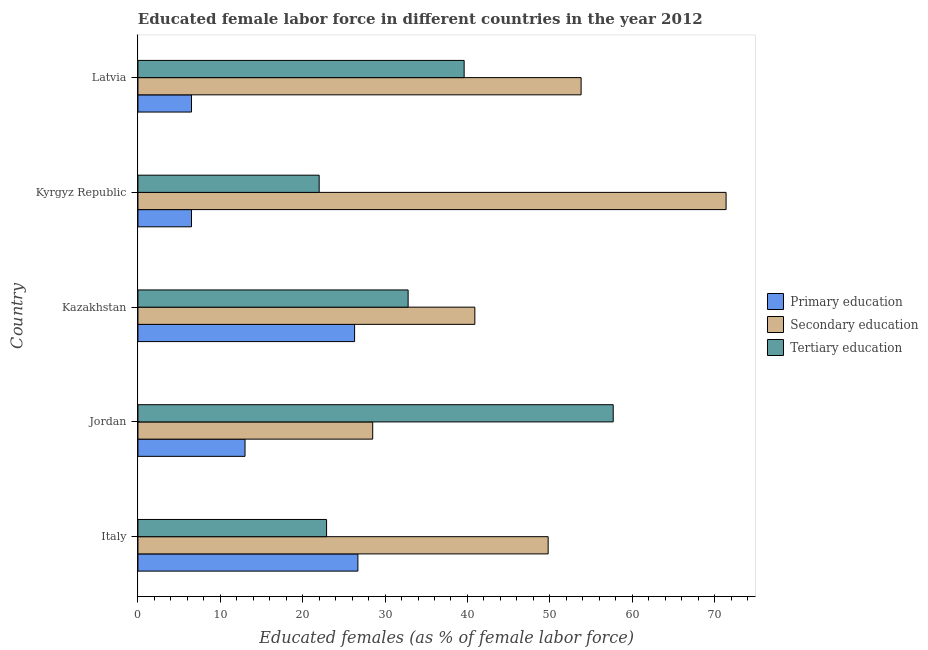How many different coloured bars are there?
Your response must be concise. 3. How many groups of bars are there?
Your response must be concise. 5. Are the number of bars per tick equal to the number of legend labels?
Your answer should be compact. Yes. How many bars are there on the 4th tick from the top?
Provide a short and direct response. 3. What is the label of the 2nd group of bars from the top?
Ensure brevity in your answer.  Kyrgyz Republic. Across all countries, what is the maximum percentage of female labor force who received tertiary education?
Your response must be concise. 57.7. Across all countries, what is the minimum percentage of female labor force who received secondary education?
Provide a short and direct response. 28.5. In which country was the percentage of female labor force who received secondary education minimum?
Keep it short and to the point. Jordan. What is the total percentage of female labor force who received secondary education in the graph?
Your answer should be compact. 244.4. What is the difference between the percentage of female labor force who received primary education in Italy and that in Jordan?
Provide a succinct answer. 13.7. What is the difference between the percentage of female labor force who received primary education in Kyrgyz Republic and the percentage of female labor force who received tertiary education in Italy?
Offer a very short reply. -16.4. What is the average percentage of female labor force who received primary education per country?
Make the answer very short. 15.8. What is the difference between the percentage of female labor force who received secondary education and percentage of female labor force who received tertiary education in Kyrgyz Republic?
Make the answer very short. 49.4. In how many countries, is the percentage of female labor force who received tertiary education greater than 58 %?
Offer a terse response. 0. What is the ratio of the percentage of female labor force who received tertiary education in Italy to that in Kazakhstan?
Ensure brevity in your answer.  0.7. What is the difference between the highest and the second highest percentage of female labor force who received primary education?
Your response must be concise. 0.4. What is the difference between the highest and the lowest percentage of female labor force who received tertiary education?
Offer a terse response. 35.7. In how many countries, is the percentage of female labor force who received secondary education greater than the average percentage of female labor force who received secondary education taken over all countries?
Your answer should be compact. 3. Is the sum of the percentage of female labor force who received tertiary education in Italy and Latvia greater than the maximum percentage of female labor force who received primary education across all countries?
Provide a short and direct response. Yes. What does the 2nd bar from the top in Kyrgyz Republic represents?
Keep it short and to the point. Secondary education. What does the 2nd bar from the bottom in Jordan represents?
Offer a terse response. Secondary education. How many countries are there in the graph?
Ensure brevity in your answer.  5. What is the difference between two consecutive major ticks on the X-axis?
Offer a very short reply. 10. Are the values on the major ticks of X-axis written in scientific E-notation?
Ensure brevity in your answer.  No. Does the graph contain any zero values?
Your answer should be compact. No. Does the graph contain grids?
Ensure brevity in your answer.  No. What is the title of the graph?
Keep it short and to the point. Educated female labor force in different countries in the year 2012. What is the label or title of the X-axis?
Offer a terse response. Educated females (as % of female labor force). What is the Educated females (as % of female labor force) in Primary education in Italy?
Your response must be concise. 26.7. What is the Educated females (as % of female labor force) of Secondary education in Italy?
Keep it short and to the point. 49.8. What is the Educated females (as % of female labor force) of Tertiary education in Italy?
Keep it short and to the point. 22.9. What is the Educated females (as % of female labor force) in Secondary education in Jordan?
Offer a very short reply. 28.5. What is the Educated females (as % of female labor force) of Tertiary education in Jordan?
Provide a succinct answer. 57.7. What is the Educated females (as % of female labor force) in Primary education in Kazakhstan?
Offer a terse response. 26.3. What is the Educated females (as % of female labor force) of Secondary education in Kazakhstan?
Ensure brevity in your answer.  40.9. What is the Educated females (as % of female labor force) of Tertiary education in Kazakhstan?
Your answer should be very brief. 32.8. What is the Educated females (as % of female labor force) in Secondary education in Kyrgyz Republic?
Keep it short and to the point. 71.4. What is the Educated females (as % of female labor force) of Secondary education in Latvia?
Ensure brevity in your answer.  53.8. What is the Educated females (as % of female labor force) of Tertiary education in Latvia?
Offer a very short reply. 39.6. Across all countries, what is the maximum Educated females (as % of female labor force) in Primary education?
Offer a very short reply. 26.7. Across all countries, what is the maximum Educated females (as % of female labor force) in Secondary education?
Your answer should be compact. 71.4. Across all countries, what is the maximum Educated females (as % of female labor force) of Tertiary education?
Provide a short and direct response. 57.7. Across all countries, what is the minimum Educated females (as % of female labor force) of Primary education?
Give a very brief answer. 6.5. Across all countries, what is the minimum Educated females (as % of female labor force) in Secondary education?
Your response must be concise. 28.5. What is the total Educated females (as % of female labor force) in Primary education in the graph?
Offer a very short reply. 79. What is the total Educated females (as % of female labor force) of Secondary education in the graph?
Give a very brief answer. 244.4. What is the total Educated females (as % of female labor force) of Tertiary education in the graph?
Provide a short and direct response. 175. What is the difference between the Educated females (as % of female labor force) of Secondary education in Italy and that in Jordan?
Offer a terse response. 21.3. What is the difference between the Educated females (as % of female labor force) in Tertiary education in Italy and that in Jordan?
Offer a very short reply. -34.8. What is the difference between the Educated females (as % of female labor force) of Tertiary education in Italy and that in Kazakhstan?
Your response must be concise. -9.9. What is the difference between the Educated females (as % of female labor force) of Primary education in Italy and that in Kyrgyz Republic?
Your response must be concise. 20.2. What is the difference between the Educated females (as % of female labor force) in Secondary education in Italy and that in Kyrgyz Republic?
Keep it short and to the point. -21.6. What is the difference between the Educated females (as % of female labor force) in Tertiary education in Italy and that in Kyrgyz Republic?
Give a very brief answer. 0.9. What is the difference between the Educated females (as % of female labor force) of Primary education in Italy and that in Latvia?
Give a very brief answer. 20.2. What is the difference between the Educated females (as % of female labor force) of Tertiary education in Italy and that in Latvia?
Ensure brevity in your answer.  -16.7. What is the difference between the Educated females (as % of female labor force) of Secondary education in Jordan and that in Kazakhstan?
Ensure brevity in your answer.  -12.4. What is the difference between the Educated females (as % of female labor force) in Tertiary education in Jordan and that in Kazakhstan?
Your response must be concise. 24.9. What is the difference between the Educated females (as % of female labor force) of Secondary education in Jordan and that in Kyrgyz Republic?
Offer a very short reply. -42.9. What is the difference between the Educated females (as % of female labor force) in Tertiary education in Jordan and that in Kyrgyz Republic?
Your response must be concise. 35.7. What is the difference between the Educated females (as % of female labor force) in Secondary education in Jordan and that in Latvia?
Provide a short and direct response. -25.3. What is the difference between the Educated females (as % of female labor force) of Tertiary education in Jordan and that in Latvia?
Offer a terse response. 18.1. What is the difference between the Educated females (as % of female labor force) in Primary education in Kazakhstan and that in Kyrgyz Republic?
Provide a short and direct response. 19.8. What is the difference between the Educated females (as % of female labor force) of Secondary education in Kazakhstan and that in Kyrgyz Republic?
Your answer should be very brief. -30.5. What is the difference between the Educated females (as % of female labor force) of Primary education in Kazakhstan and that in Latvia?
Your answer should be compact. 19.8. What is the difference between the Educated females (as % of female labor force) of Secondary education in Kazakhstan and that in Latvia?
Your answer should be very brief. -12.9. What is the difference between the Educated females (as % of female labor force) in Tertiary education in Kazakhstan and that in Latvia?
Ensure brevity in your answer.  -6.8. What is the difference between the Educated females (as % of female labor force) in Primary education in Kyrgyz Republic and that in Latvia?
Give a very brief answer. 0. What is the difference between the Educated females (as % of female labor force) of Secondary education in Kyrgyz Republic and that in Latvia?
Make the answer very short. 17.6. What is the difference between the Educated females (as % of female labor force) in Tertiary education in Kyrgyz Republic and that in Latvia?
Your response must be concise. -17.6. What is the difference between the Educated females (as % of female labor force) in Primary education in Italy and the Educated females (as % of female labor force) in Secondary education in Jordan?
Ensure brevity in your answer.  -1.8. What is the difference between the Educated females (as % of female labor force) of Primary education in Italy and the Educated females (as % of female labor force) of Tertiary education in Jordan?
Offer a terse response. -31. What is the difference between the Educated females (as % of female labor force) of Secondary education in Italy and the Educated females (as % of female labor force) of Tertiary education in Jordan?
Keep it short and to the point. -7.9. What is the difference between the Educated females (as % of female labor force) of Secondary education in Italy and the Educated females (as % of female labor force) of Tertiary education in Kazakhstan?
Your answer should be very brief. 17. What is the difference between the Educated females (as % of female labor force) in Primary education in Italy and the Educated females (as % of female labor force) in Secondary education in Kyrgyz Republic?
Your answer should be compact. -44.7. What is the difference between the Educated females (as % of female labor force) of Primary education in Italy and the Educated females (as % of female labor force) of Tertiary education in Kyrgyz Republic?
Provide a succinct answer. 4.7. What is the difference between the Educated females (as % of female labor force) in Secondary education in Italy and the Educated females (as % of female labor force) in Tertiary education in Kyrgyz Republic?
Offer a terse response. 27.8. What is the difference between the Educated females (as % of female labor force) of Primary education in Italy and the Educated females (as % of female labor force) of Secondary education in Latvia?
Your response must be concise. -27.1. What is the difference between the Educated females (as % of female labor force) in Secondary education in Italy and the Educated females (as % of female labor force) in Tertiary education in Latvia?
Offer a terse response. 10.2. What is the difference between the Educated females (as % of female labor force) of Primary education in Jordan and the Educated females (as % of female labor force) of Secondary education in Kazakhstan?
Give a very brief answer. -27.9. What is the difference between the Educated females (as % of female labor force) of Primary education in Jordan and the Educated females (as % of female labor force) of Tertiary education in Kazakhstan?
Ensure brevity in your answer.  -19.8. What is the difference between the Educated females (as % of female labor force) in Primary education in Jordan and the Educated females (as % of female labor force) in Secondary education in Kyrgyz Republic?
Your answer should be compact. -58.4. What is the difference between the Educated females (as % of female labor force) of Primary education in Jordan and the Educated females (as % of female labor force) of Tertiary education in Kyrgyz Republic?
Ensure brevity in your answer.  -9. What is the difference between the Educated females (as % of female labor force) of Primary education in Jordan and the Educated females (as % of female labor force) of Secondary education in Latvia?
Provide a short and direct response. -40.8. What is the difference between the Educated females (as % of female labor force) in Primary education in Jordan and the Educated females (as % of female labor force) in Tertiary education in Latvia?
Provide a succinct answer. -26.6. What is the difference between the Educated females (as % of female labor force) of Primary education in Kazakhstan and the Educated females (as % of female labor force) of Secondary education in Kyrgyz Republic?
Provide a succinct answer. -45.1. What is the difference between the Educated females (as % of female labor force) in Primary education in Kazakhstan and the Educated females (as % of female labor force) in Secondary education in Latvia?
Keep it short and to the point. -27.5. What is the difference between the Educated females (as % of female labor force) in Primary education in Kazakhstan and the Educated females (as % of female labor force) in Tertiary education in Latvia?
Provide a short and direct response. -13.3. What is the difference between the Educated females (as % of female labor force) in Primary education in Kyrgyz Republic and the Educated females (as % of female labor force) in Secondary education in Latvia?
Provide a short and direct response. -47.3. What is the difference between the Educated females (as % of female labor force) in Primary education in Kyrgyz Republic and the Educated females (as % of female labor force) in Tertiary education in Latvia?
Your answer should be very brief. -33.1. What is the difference between the Educated females (as % of female labor force) of Secondary education in Kyrgyz Republic and the Educated females (as % of female labor force) of Tertiary education in Latvia?
Your answer should be compact. 31.8. What is the average Educated females (as % of female labor force) in Primary education per country?
Your response must be concise. 15.8. What is the average Educated females (as % of female labor force) in Secondary education per country?
Give a very brief answer. 48.88. What is the average Educated females (as % of female labor force) of Tertiary education per country?
Provide a succinct answer. 35. What is the difference between the Educated females (as % of female labor force) of Primary education and Educated females (as % of female labor force) of Secondary education in Italy?
Your answer should be very brief. -23.1. What is the difference between the Educated females (as % of female labor force) in Primary education and Educated females (as % of female labor force) in Tertiary education in Italy?
Offer a terse response. 3.8. What is the difference between the Educated females (as % of female labor force) in Secondary education and Educated females (as % of female labor force) in Tertiary education in Italy?
Give a very brief answer. 26.9. What is the difference between the Educated females (as % of female labor force) in Primary education and Educated females (as % of female labor force) in Secondary education in Jordan?
Provide a short and direct response. -15.5. What is the difference between the Educated females (as % of female labor force) in Primary education and Educated females (as % of female labor force) in Tertiary education in Jordan?
Your answer should be very brief. -44.7. What is the difference between the Educated females (as % of female labor force) of Secondary education and Educated females (as % of female labor force) of Tertiary education in Jordan?
Ensure brevity in your answer.  -29.2. What is the difference between the Educated females (as % of female labor force) in Primary education and Educated females (as % of female labor force) in Secondary education in Kazakhstan?
Keep it short and to the point. -14.6. What is the difference between the Educated females (as % of female labor force) in Primary education and Educated females (as % of female labor force) in Tertiary education in Kazakhstan?
Your answer should be very brief. -6.5. What is the difference between the Educated females (as % of female labor force) of Primary education and Educated females (as % of female labor force) of Secondary education in Kyrgyz Republic?
Keep it short and to the point. -64.9. What is the difference between the Educated females (as % of female labor force) of Primary education and Educated females (as % of female labor force) of Tertiary education in Kyrgyz Republic?
Make the answer very short. -15.5. What is the difference between the Educated females (as % of female labor force) of Secondary education and Educated females (as % of female labor force) of Tertiary education in Kyrgyz Republic?
Your answer should be compact. 49.4. What is the difference between the Educated females (as % of female labor force) of Primary education and Educated females (as % of female labor force) of Secondary education in Latvia?
Make the answer very short. -47.3. What is the difference between the Educated females (as % of female labor force) in Primary education and Educated females (as % of female labor force) in Tertiary education in Latvia?
Ensure brevity in your answer.  -33.1. What is the difference between the Educated females (as % of female labor force) of Secondary education and Educated females (as % of female labor force) of Tertiary education in Latvia?
Provide a succinct answer. 14.2. What is the ratio of the Educated females (as % of female labor force) of Primary education in Italy to that in Jordan?
Your answer should be compact. 2.05. What is the ratio of the Educated females (as % of female labor force) of Secondary education in Italy to that in Jordan?
Your response must be concise. 1.75. What is the ratio of the Educated females (as % of female labor force) of Tertiary education in Italy to that in Jordan?
Give a very brief answer. 0.4. What is the ratio of the Educated females (as % of female labor force) in Primary education in Italy to that in Kazakhstan?
Give a very brief answer. 1.02. What is the ratio of the Educated females (as % of female labor force) of Secondary education in Italy to that in Kazakhstan?
Make the answer very short. 1.22. What is the ratio of the Educated females (as % of female labor force) of Tertiary education in Italy to that in Kazakhstan?
Offer a terse response. 0.7. What is the ratio of the Educated females (as % of female labor force) of Primary education in Italy to that in Kyrgyz Republic?
Give a very brief answer. 4.11. What is the ratio of the Educated females (as % of female labor force) of Secondary education in Italy to that in Kyrgyz Republic?
Offer a terse response. 0.7. What is the ratio of the Educated females (as % of female labor force) of Tertiary education in Italy to that in Kyrgyz Republic?
Keep it short and to the point. 1.04. What is the ratio of the Educated females (as % of female labor force) in Primary education in Italy to that in Latvia?
Offer a very short reply. 4.11. What is the ratio of the Educated females (as % of female labor force) in Secondary education in Italy to that in Latvia?
Offer a terse response. 0.93. What is the ratio of the Educated females (as % of female labor force) of Tertiary education in Italy to that in Latvia?
Offer a terse response. 0.58. What is the ratio of the Educated females (as % of female labor force) in Primary education in Jordan to that in Kazakhstan?
Make the answer very short. 0.49. What is the ratio of the Educated females (as % of female labor force) of Secondary education in Jordan to that in Kazakhstan?
Your response must be concise. 0.7. What is the ratio of the Educated females (as % of female labor force) in Tertiary education in Jordan to that in Kazakhstan?
Offer a very short reply. 1.76. What is the ratio of the Educated females (as % of female labor force) of Secondary education in Jordan to that in Kyrgyz Republic?
Your response must be concise. 0.4. What is the ratio of the Educated females (as % of female labor force) of Tertiary education in Jordan to that in Kyrgyz Republic?
Offer a very short reply. 2.62. What is the ratio of the Educated females (as % of female labor force) of Primary education in Jordan to that in Latvia?
Your answer should be very brief. 2. What is the ratio of the Educated females (as % of female labor force) in Secondary education in Jordan to that in Latvia?
Your answer should be very brief. 0.53. What is the ratio of the Educated females (as % of female labor force) in Tertiary education in Jordan to that in Latvia?
Offer a very short reply. 1.46. What is the ratio of the Educated females (as % of female labor force) in Primary education in Kazakhstan to that in Kyrgyz Republic?
Offer a very short reply. 4.05. What is the ratio of the Educated females (as % of female labor force) in Secondary education in Kazakhstan to that in Kyrgyz Republic?
Your answer should be compact. 0.57. What is the ratio of the Educated females (as % of female labor force) of Tertiary education in Kazakhstan to that in Kyrgyz Republic?
Offer a very short reply. 1.49. What is the ratio of the Educated females (as % of female labor force) in Primary education in Kazakhstan to that in Latvia?
Offer a terse response. 4.05. What is the ratio of the Educated females (as % of female labor force) of Secondary education in Kazakhstan to that in Latvia?
Offer a very short reply. 0.76. What is the ratio of the Educated females (as % of female labor force) of Tertiary education in Kazakhstan to that in Latvia?
Your answer should be compact. 0.83. What is the ratio of the Educated females (as % of female labor force) in Primary education in Kyrgyz Republic to that in Latvia?
Your answer should be compact. 1. What is the ratio of the Educated females (as % of female labor force) in Secondary education in Kyrgyz Republic to that in Latvia?
Your response must be concise. 1.33. What is the ratio of the Educated females (as % of female labor force) of Tertiary education in Kyrgyz Republic to that in Latvia?
Provide a succinct answer. 0.56. What is the difference between the highest and the lowest Educated females (as % of female labor force) in Primary education?
Offer a terse response. 20.2. What is the difference between the highest and the lowest Educated females (as % of female labor force) in Secondary education?
Provide a succinct answer. 42.9. What is the difference between the highest and the lowest Educated females (as % of female labor force) of Tertiary education?
Ensure brevity in your answer.  35.7. 